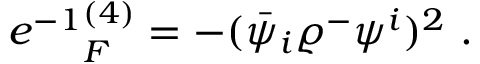<formula> <loc_0><loc_0><loc_500><loc_500>e ^ { - 1 } \L _ { F } ^ { ( 4 ) } = - ( \bar { \psi } _ { i } \varrho ^ { - } \psi ^ { i } ) ^ { 2 } \ .</formula> 